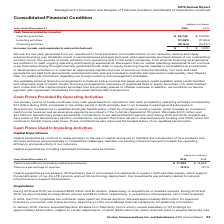According to Verizon Communications's financial document, How is the capital spending requirements for the firm financed? primarily through internally generated funds. The document states: "pending requirements will continue to be financed primarily through internally generated funds. Debt or equity financing may be needed to fund additio..." Also, What are the available external financing arrangements? Based on the financial document, the answer is active commercial paper program, credit available under credit facilities and other bank lines of credit, vendor financing arrangements, issuances of registered debt or equity securities, U.S. retail medium-term notes and other capital market securities that are privately-placed or offered overseas. Also, What was the cash flow from operating activities in 2019? According to the financial document, $ 35,746 (in millions). The relevant text states: "Operating activities $ 35,746 $ 34,339..." Also, can you calculate: What was the change in cash flow from operating activities from 2018 to 2019? Based on the calculation: 35,746 - 34,339, the result is 1407 (in millions). This is based on the information: "Operating activities $ 35,746 $ 34,339 Operating activities $ 35,746 $ 34,339..." The key data points involved are: 34,339, 35,746. Also, can you calculate: What was the average cash flow used in investing activities for 2018 and 2019? To answer this question, I need to perform calculations using the financial data. The calculation is: -(17,581 + 17,934) / 2, which equals -17757.5 (in millions). This is based on the information: "Investing activities (17,581) (17,934) Investing activities (17,581) (17,934)..." The key data points involved are: 17,581, 17,934. Also, can you calculate: What was the percentage change in cash flow used in financing activities from 2018 to 2019? To answer this question, I need to perform calculations using the financial data. The calculation is: -18,164 / -15,377 - 1, which equals 18.12 (percentage). This is based on the information: "Financing activities (18,164) (15,377) Financing activities (18,164) (15,377)..." The key data points involved are: 15,377, 18,164. 